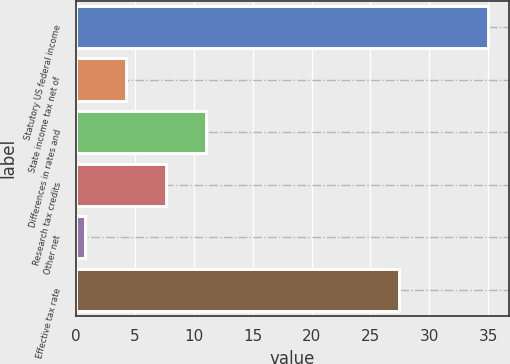Convert chart. <chart><loc_0><loc_0><loc_500><loc_500><bar_chart><fcel>Statutory US federal income<fcel>State income tax net of<fcel>Differences in rates and<fcel>Research tax credits<fcel>Other net<fcel>Effective tax rate<nl><fcel>35<fcel>4.22<fcel>11.06<fcel>7.64<fcel>0.8<fcel>27.4<nl></chart> 